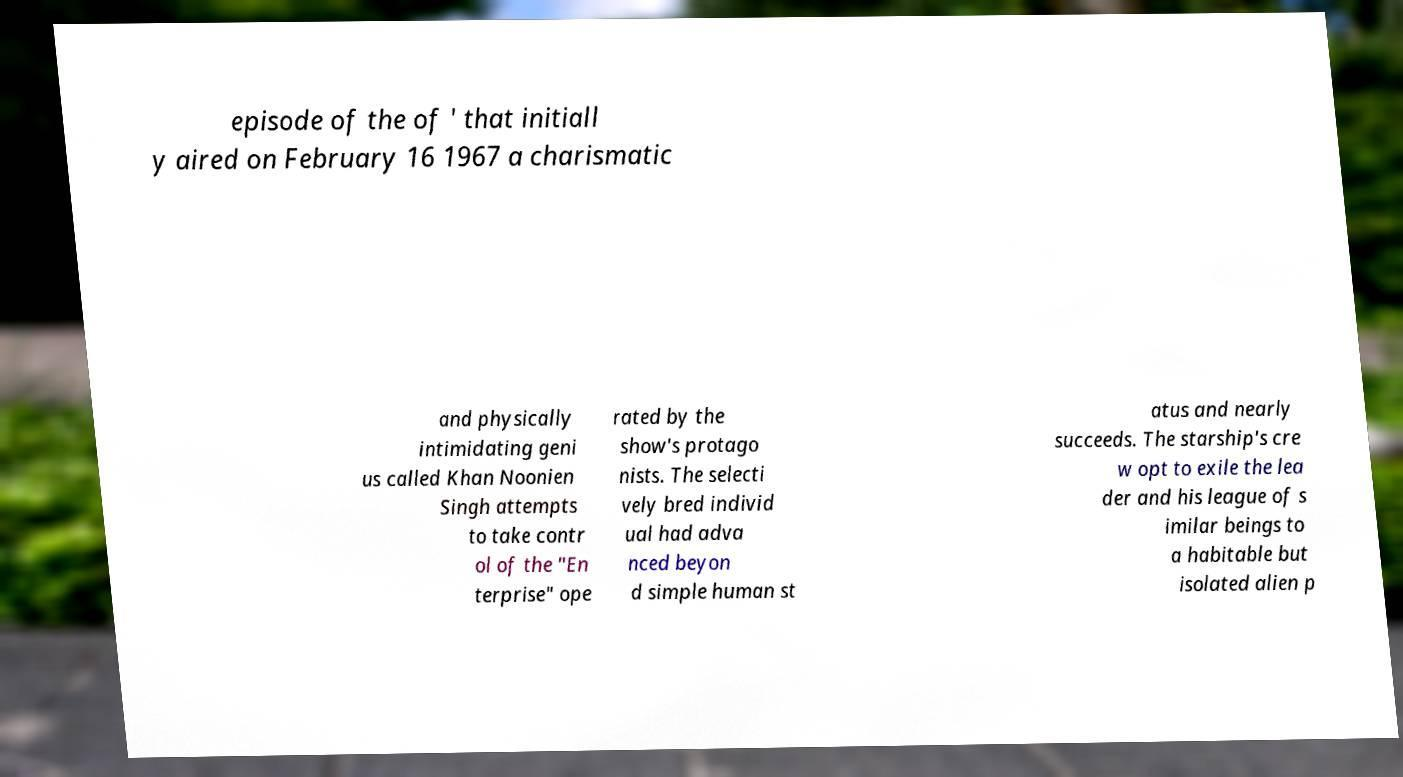What messages or text are displayed in this image? I need them in a readable, typed format. episode of the of ' that initiall y aired on February 16 1967 a charismatic and physically intimidating geni us called Khan Noonien Singh attempts to take contr ol of the "En terprise" ope rated by the show's protago nists. The selecti vely bred individ ual had adva nced beyon d simple human st atus and nearly succeeds. The starship's cre w opt to exile the lea der and his league of s imilar beings to a habitable but isolated alien p 